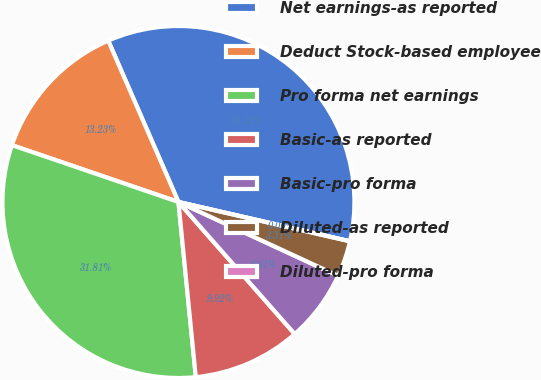Convert chart. <chart><loc_0><loc_0><loc_500><loc_500><pie_chart><fcel>Net earnings-as reported<fcel>Deduct Stock-based employee<fcel>Pro forma net earnings<fcel>Basic-as reported<fcel>Basic-pro forma<fcel>Diluted-as reported<fcel>Diluted-pro forma<nl><fcel>35.12%<fcel>13.23%<fcel>31.81%<fcel>9.92%<fcel>6.61%<fcel>3.31%<fcel>0.0%<nl></chart> 